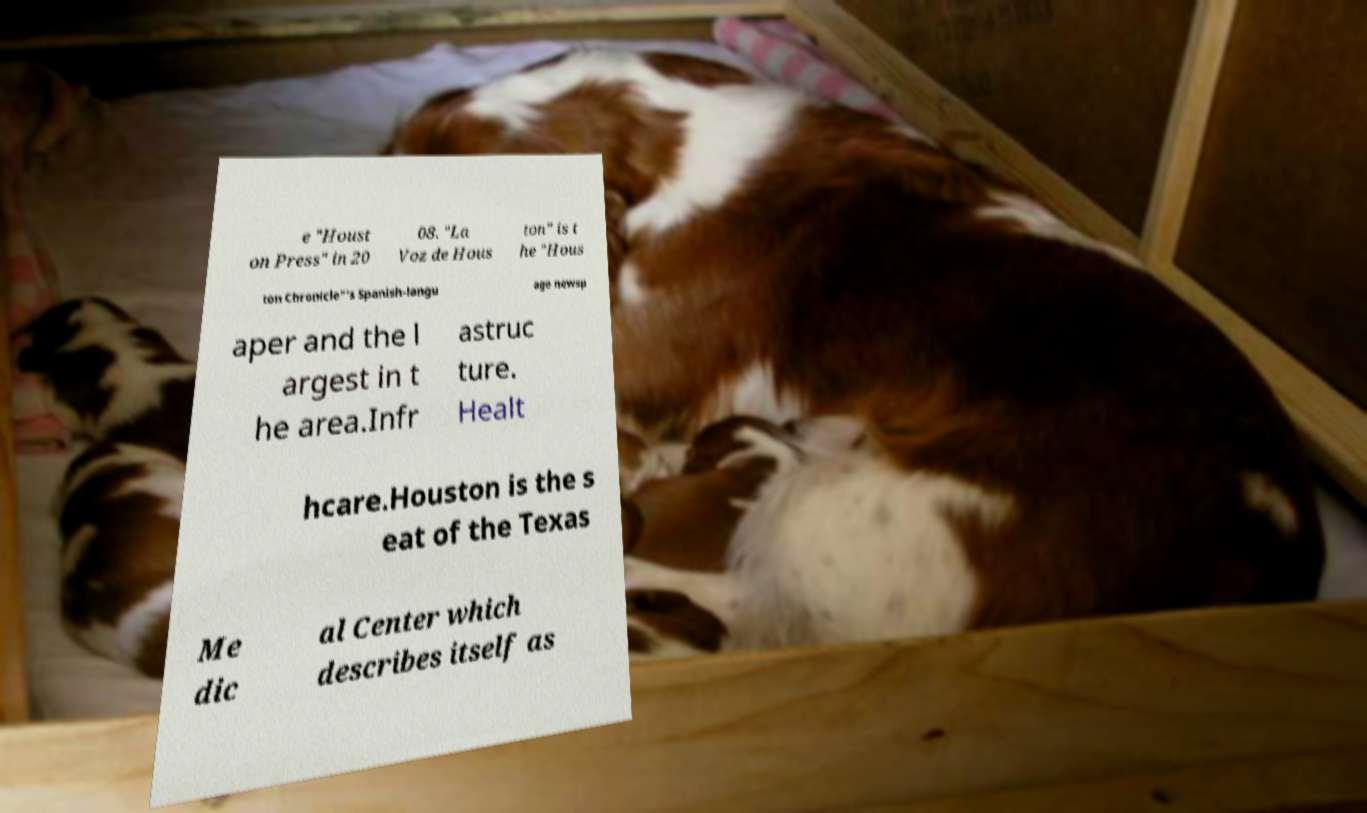Could you assist in decoding the text presented in this image and type it out clearly? e "Houst on Press" in 20 08. "La Voz de Hous ton" is t he "Hous ton Chronicle"'s Spanish-langu age newsp aper and the l argest in t he area.Infr astruc ture. Healt hcare.Houston is the s eat of the Texas Me dic al Center which describes itself as 